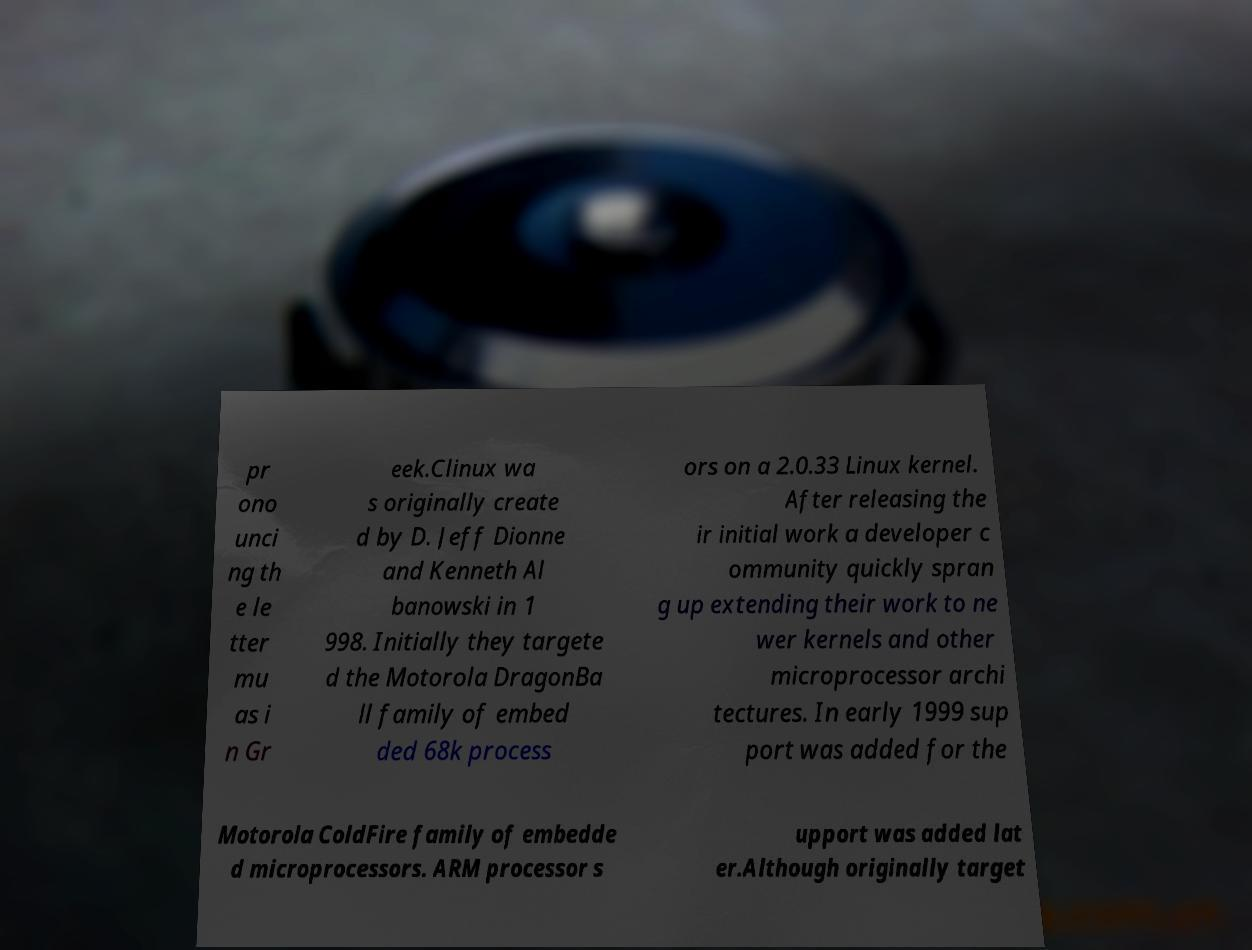Could you extract and type out the text from this image? pr ono unci ng th e le tter mu as i n Gr eek.Clinux wa s originally create d by D. Jeff Dionne and Kenneth Al banowski in 1 998. Initially they targete d the Motorola DragonBa ll family of embed ded 68k process ors on a 2.0.33 Linux kernel. After releasing the ir initial work a developer c ommunity quickly spran g up extending their work to ne wer kernels and other microprocessor archi tectures. In early 1999 sup port was added for the Motorola ColdFire family of embedde d microprocessors. ARM processor s upport was added lat er.Although originally target 